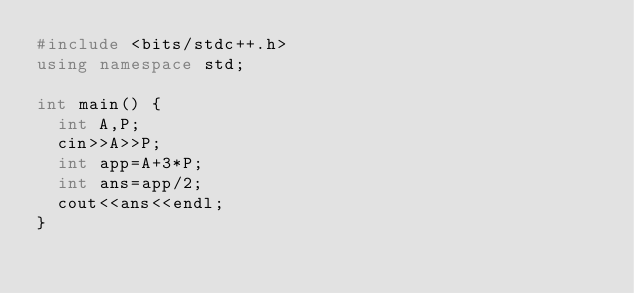<code> <loc_0><loc_0><loc_500><loc_500><_C++_>#include <bits/stdc++.h>
using namespace std;

int main() {
  int A,P;
  cin>>A>>P;
  int app=A+3*P;
  int ans=app/2;
  cout<<ans<<endl;
}
</code> 